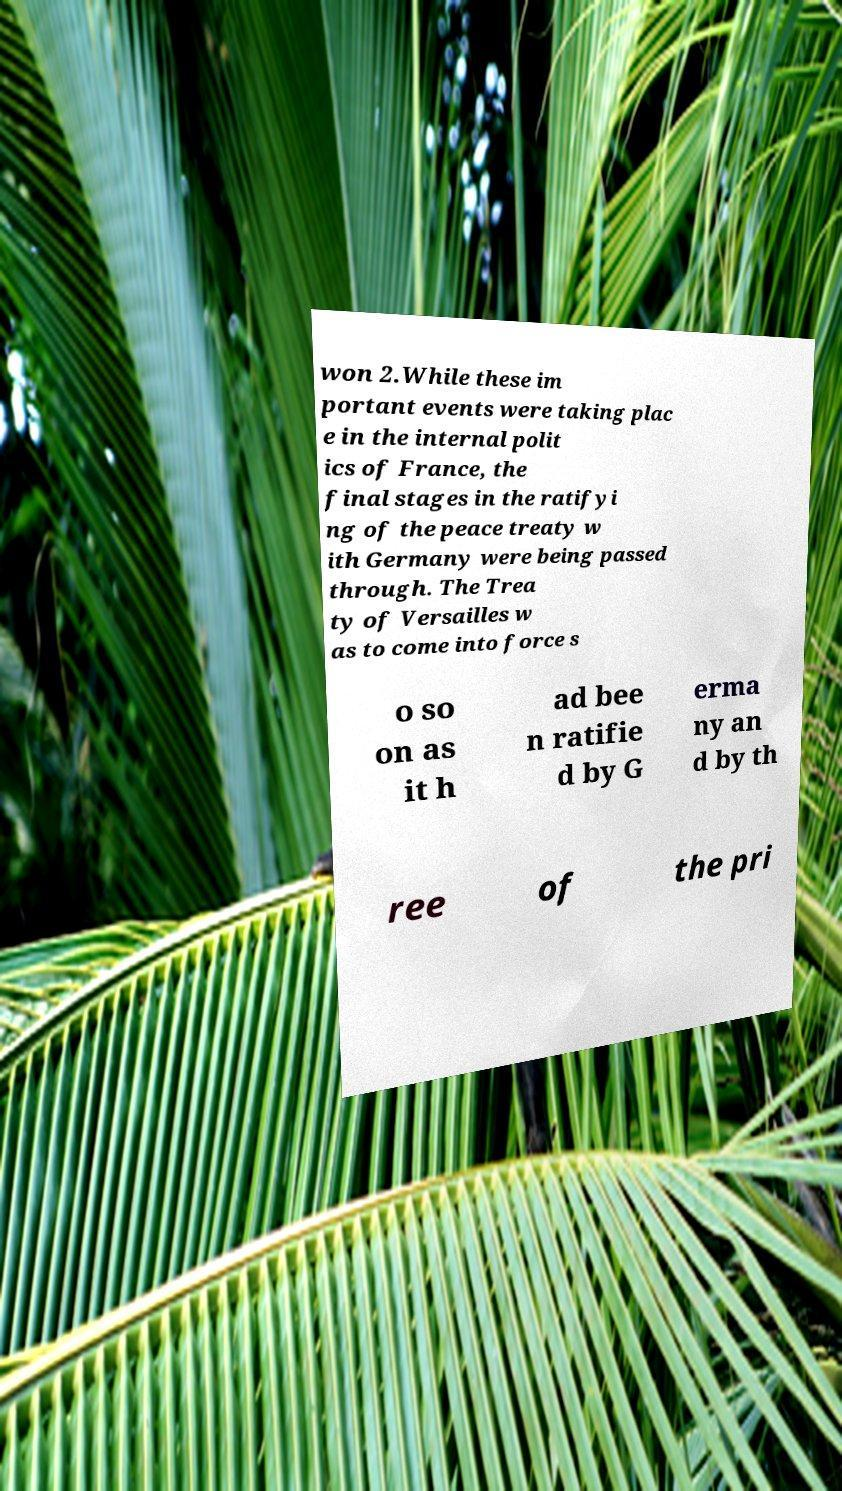Can you accurately transcribe the text from the provided image for me? won 2.While these im portant events were taking plac e in the internal polit ics of France, the final stages in the ratifyi ng of the peace treaty w ith Germany were being passed through. The Trea ty of Versailles w as to come into force s o so on as it h ad bee n ratifie d by G erma ny an d by th ree of the pri 